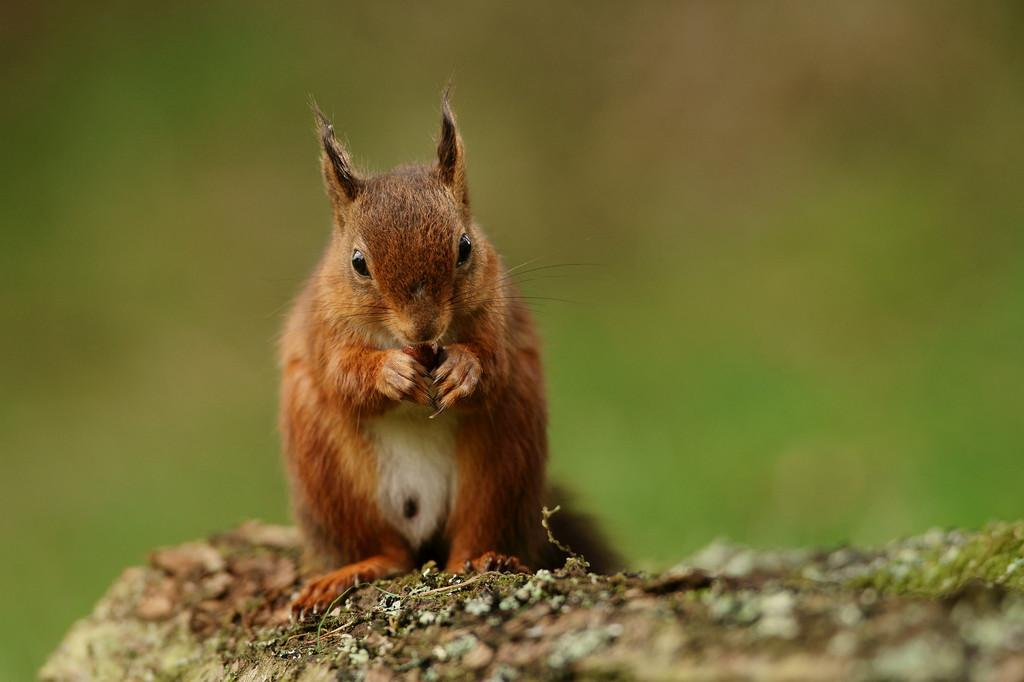What type of animal is in the image? There is a brown squirrel in the image. What is the squirrel holding in its mouth? The squirrel is holding a nut. Where is the squirrel standing? The squirrel is standing on a rock. Can you describe the background of the image? The background of the image is blurry. What type of crack is the squirrel using to open the nut in the image? There is no crack present in the image, nor is the squirrel attempting to open the nut. 